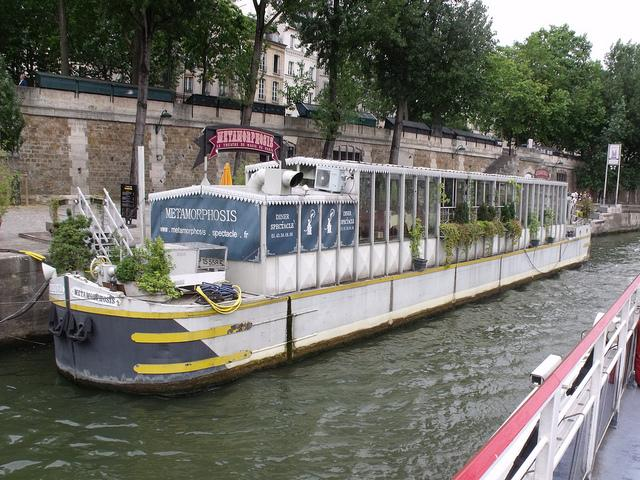Who wrote a book whose title matches the word at the front top of the boat?

Choices:
A) joe hill
B) franz kafka
C) jack ryan
D) jim sturgess franz kafka 